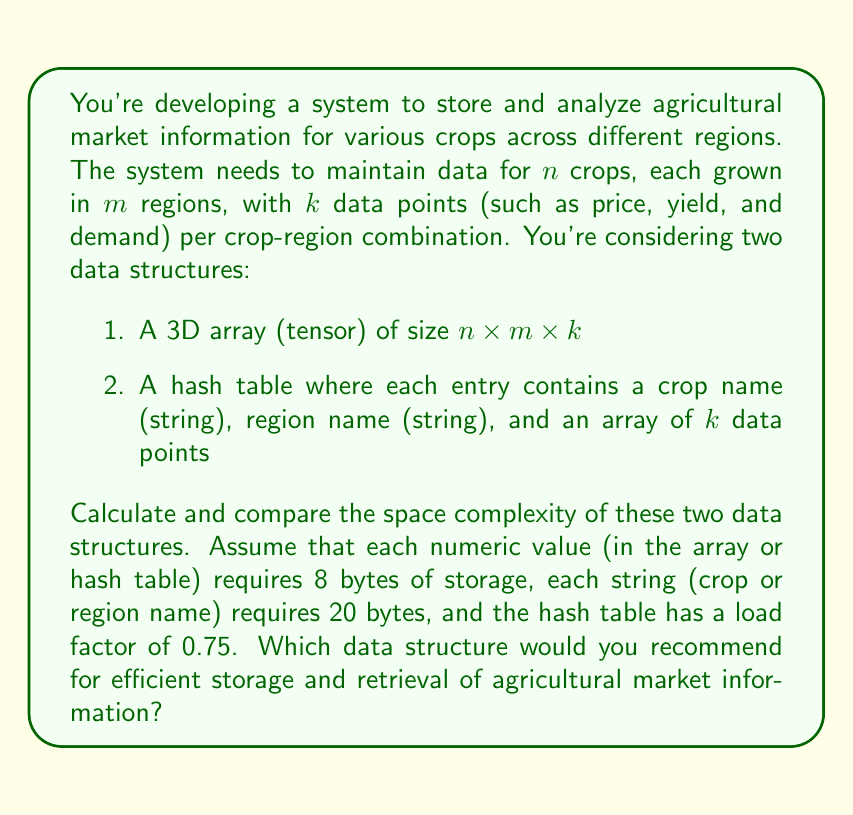Solve this math problem. Let's analyze the space complexity of both data structures:

1. 3D Array (Tensor):
   - Size: $n \times m \times k$
   - Each element is a numeric value (8 bytes)
   - Total space: $8 \times n \times m \times k$ bytes

2. Hash Table:
   - Number of entries: $n \times m$
   - Each entry contains:
     * Crop name (string): 20 bytes
     * Region name (string): 20 bytes
     * Array of $k$ data points: $8 \times k$ bytes
   - Total space per entry: $40 + 8k$ bytes
   - With a load factor of 0.75, the actual number of buckets is $\frac{n \times m}{0.75}$
   - Total space: $\frac{n \times m}{0.75} \times (40 + 8k)$ bytes

Now, let's compare the space complexities:

3D Array: $O(nmk)$
Hash Table: $O(nm)$ (considering $k$ as a constant)

The 3D array has a straightforward space complexity of $O(nmk)$, which directly reflects the total number of data points stored.

The hash table's space complexity is $O(nm)$ because the number of entries is determined by the number of crop-region combinations. The $k$ data points per entry don't affect the asymptotic complexity as they're considered constant.

However, the actual space used by the hash table might be larger due to:
1. Overhead of storing strings (crop and region names)
2. Additional space required to maintain the load factor

For large values of $n$ and $m$, the 3D array would be more space-efficient, especially if $k$ is small. The array also provides faster access times with $O(1)$ indexing.

The hash table would be more flexible for sparse data or when quick lookups by crop and region names are required. It also allows for easy addition or removal of crop-region combinations.

Recommendation:
If the data is dense (most crop-region combinations have data) and $k$ is relatively small, use the 3D array for better space efficiency and faster access.
If the data is sparse, $k$ is large, or flexibility in adding/removing entries is important, use the hash table.
Answer: Space complexity:
3D Array: $O(nmk)$
Hash Table: $O(nm)$

Recommendation: Choose based on data characteristics and access patterns. Use 3D array for dense data with small $k$, and hash table for sparse data, large $k$, or when flexibility is needed. 